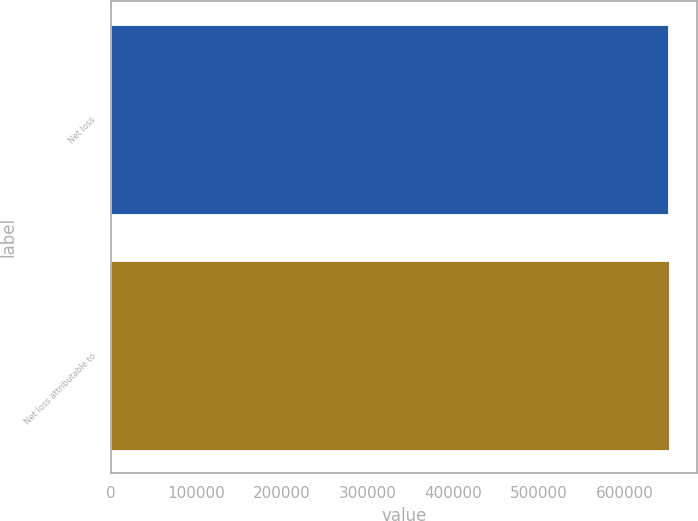<chart> <loc_0><loc_0><loc_500><loc_500><bar_chart><fcel>Net loss<fcel>Net loss attributable to<nl><fcel>650326<fcel>651472<nl></chart> 